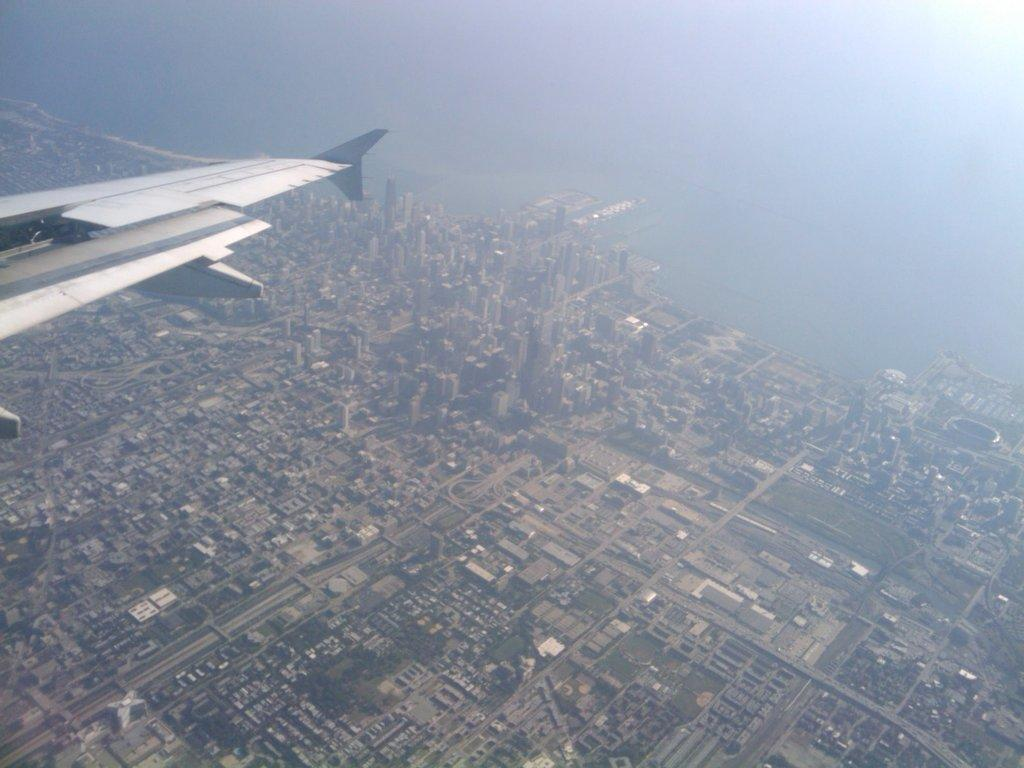What type of view is shown in the image? The image is an aerial view. What can be seen from this aerial view? The aerial view is of a city. What type of book is being read by the honey in the image? There is no book or honey present in the image, as it is an aerial view of a city. 